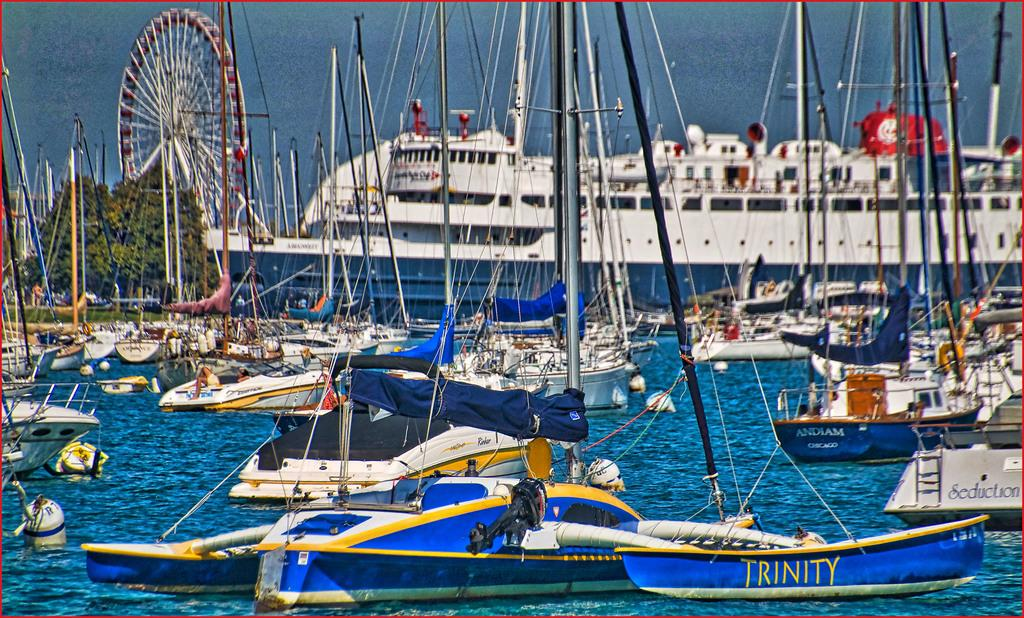What is located in the foreground of the picture? There are boats, a ship, trees, people, and a ferris wheel in the foreground of the picture. What type of environment is depicted in the foreground of the picture? The foreground of the picture features a mix of land and water elements. Can you describe the water in the foreground of the picture? There is water in the foreground of the picture, and it is also visible in the background. What type of teeth can be seen on the ferris wheel in the image? There are no teeth present on the ferris wheel in the image. What type of war is depicted in the image? There is no war depicted in the image; it features a mix of land and water elements with various structures and people. 